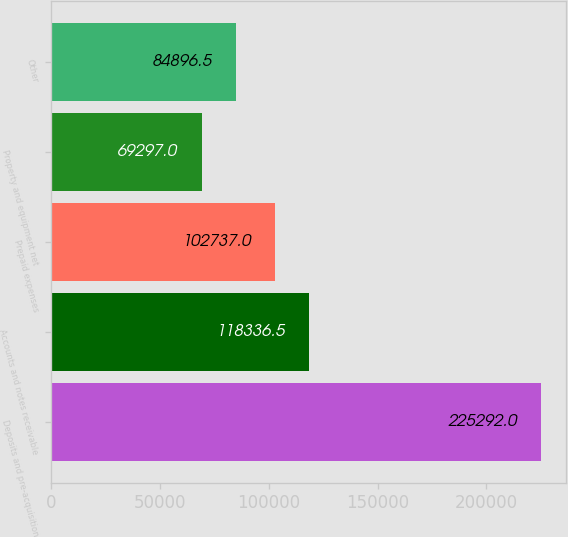Convert chart to OTSL. <chart><loc_0><loc_0><loc_500><loc_500><bar_chart><fcel>Deposits and pre-acquisition<fcel>Accounts and notes receivable<fcel>Prepaid expenses<fcel>Property and equipment net<fcel>Other<nl><fcel>225292<fcel>118336<fcel>102737<fcel>69297<fcel>84896.5<nl></chart> 